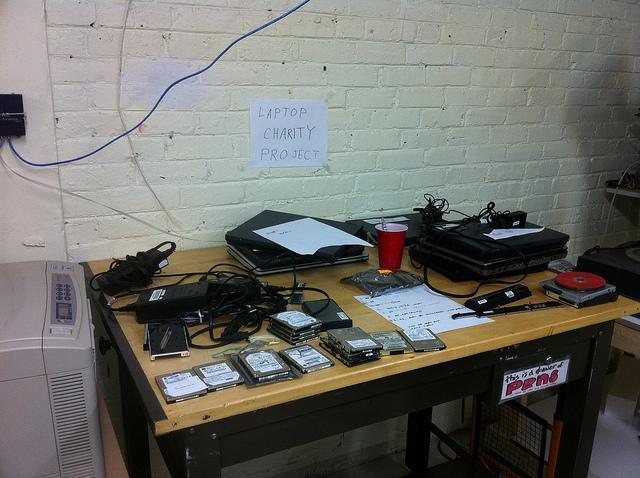How many laptops can be seen?
Give a very brief answer. 2. How many bears are there?
Give a very brief answer. 0. 